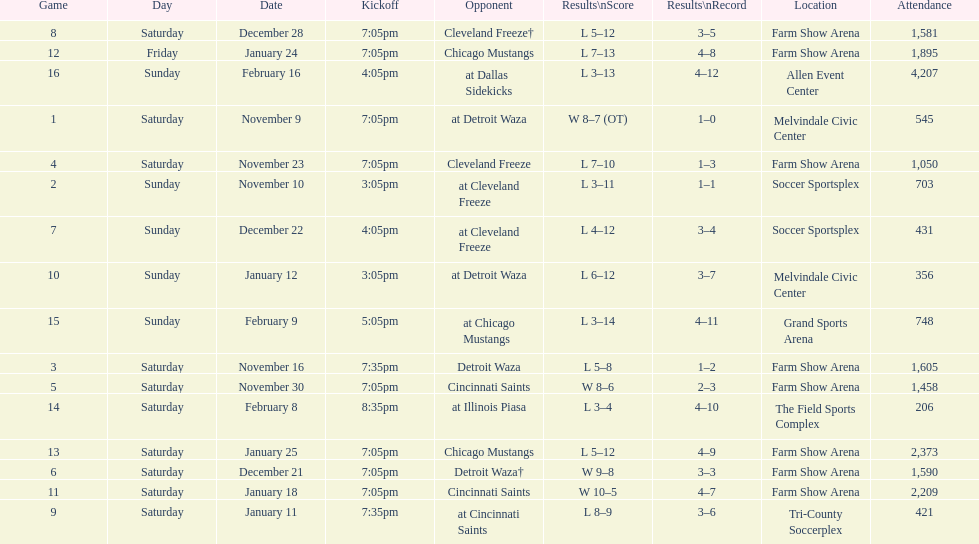Who was the first opponent on this list? Detroit Waza. 